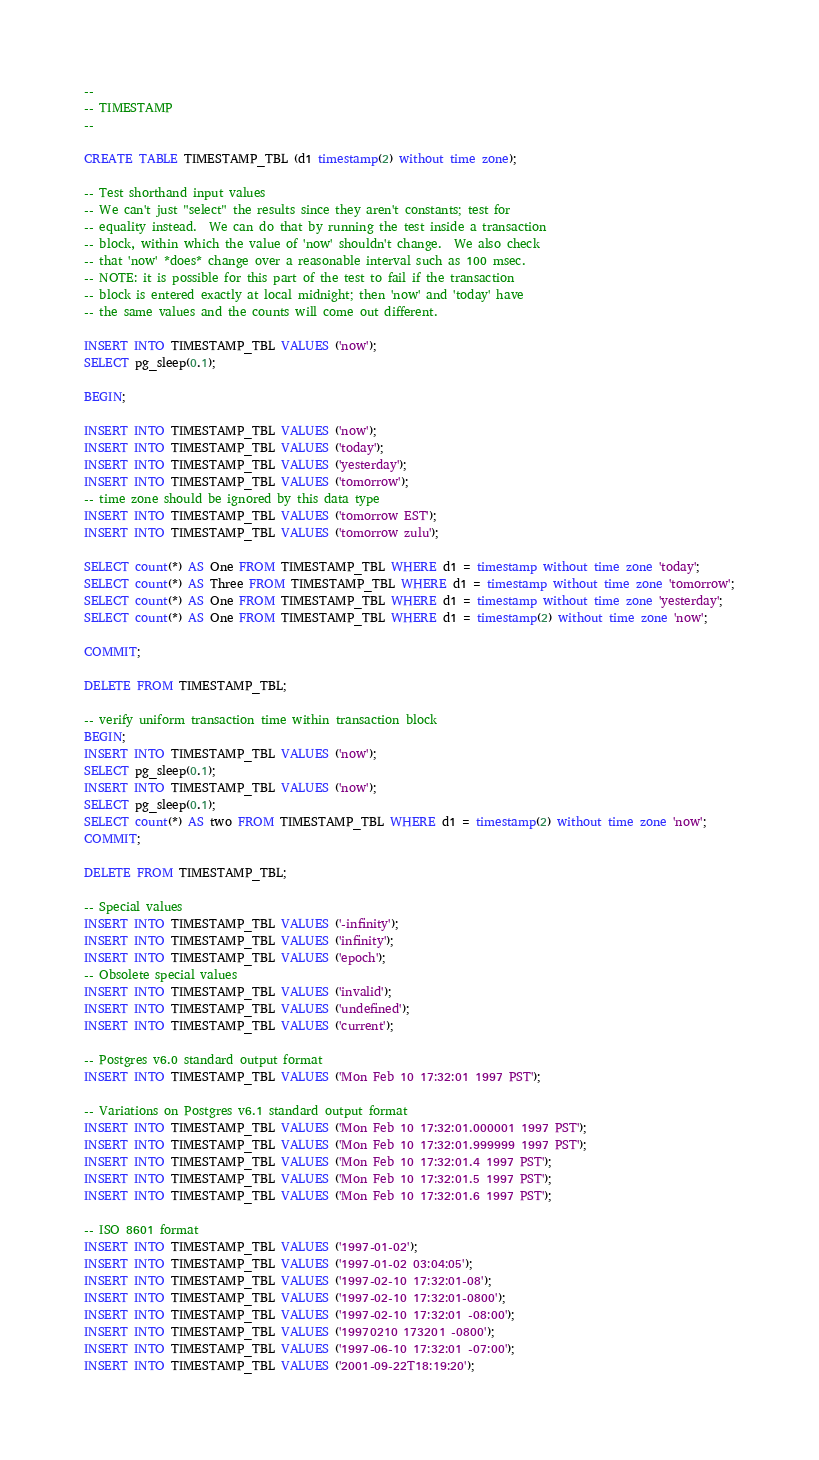<code> <loc_0><loc_0><loc_500><loc_500><_SQL_>--
-- TIMESTAMP
--

CREATE TABLE TIMESTAMP_TBL (d1 timestamp(2) without time zone);

-- Test shorthand input values
-- We can't just "select" the results since they aren't constants; test for
-- equality instead.  We can do that by running the test inside a transaction
-- block, within which the value of 'now' shouldn't change.  We also check
-- that 'now' *does* change over a reasonable interval such as 100 msec.
-- NOTE: it is possible for this part of the test to fail if the transaction
-- block is entered exactly at local midnight; then 'now' and 'today' have
-- the same values and the counts will come out different.

INSERT INTO TIMESTAMP_TBL VALUES ('now');
SELECT pg_sleep(0.1);

BEGIN;

INSERT INTO TIMESTAMP_TBL VALUES ('now');
INSERT INTO TIMESTAMP_TBL VALUES ('today');
INSERT INTO TIMESTAMP_TBL VALUES ('yesterday');
INSERT INTO TIMESTAMP_TBL VALUES ('tomorrow');
-- time zone should be ignored by this data type
INSERT INTO TIMESTAMP_TBL VALUES ('tomorrow EST');
INSERT INTO TIMESTAMP_TBL VALUES ('tomorrow zulu');

SELECT count(*) AS One FROM TIMESTAMP_TBL WHERE d1 = timestamp without time zone 'today';
SELECT count(*) AS Three FROM TIMESTAMP_TBL WHERE d1 = timestamp without time zone 'tomorrow';
SELECT count(*) AS One FROM TIMESTAMP_TBL WHERE d1 = timestamp without time zone 'yesterday';
SELECT count(*) AS One FROM TIMESTAMP_TBL WHERE d1 = timestamp(2) without time zone 'now';

COMMIT;

DELETE FROM TIMESTAMP_TBL;

-- verify uniform transaction time within transaction block
BEGIN;
INSERT INTO TIMESTAMP_TBL VALUES ('now');
SELECT pg_sleep(0.1);
INSERT INTO TIMESTAMP_TBL VALUES ('now');
SELECT pg_sleep(0.1);
SELECT count(*) AS two FROM TIMESTAMP_TBL WHERE d1 = timestamp(2) without time zone 'now';
COMMIT;

DELETE FROM TIMESTAMP_TBL;

-- Special values
INSERT INTO TIMESTAMP_TBL VALUES ('-infinity');
INSERT INTO TIMESTAMP_TBL VALUES ('infinity');
INSERT INTO TIMESTAMP_TBL VALUES ('epoch');
-- Obsolete special values
INSERT INTO TIMESTAMP_TBL VALUES ('invalid');
INSERT INTO TIMESTAMP_TBL VALUES ('undefined');
INSERT INTO TIMESTAMP_TBL VALUES ('current');

-- Postgres v6.0 standard output format
INSERT INTO TIMESTAMP_TBL VALUES ('Mon Feb 10 17:32:01 1997 PST');

-- Variations on Postgres v6.1 standard output format
INSERT INTO TIMESTAMP_TBL VALUES ('Mon Feb 10 17:32:01.000001 1997 PST');
INSERT INTO TIMESTAMP_TBL VALUES ('Mon Feb 10 17:32:01.999999 1997 PST');
INSERT INTO TIMESTAMP_TBL VALUES ('Mon Feb 10 17:32:01.4 1997 PST');
INSERT INTO TIMESTAMP_TBL VALUES ('Mon Feb 10 17:32:01.5 1997 PST');
INSERT INTO TIMESTAMP_TBL VALUES ('Mon Feb 10 17:32:01.6 1997 PST');

-- ISO 8601 format
INSERT INTO TIMESTAMP_TBL VALUES ('1997-01-02');
INSERT INTO TIMESTAMP_TBL VALUES ('1997-01-02 03:04:05');
INSERT INTO TIMESTAMP_TBL VALUES ('1997-02-10 17:32:01-08');
INSERT INTO TIMESTAMP_TBL VALUES ('1997-02-10 17:32:01-0800');
INSERT INTO TIMESTAMP_TBL VALUES ('1997-02-10 17:32:01 -08:00');
INSERT INTO TIMESTAMP_TBL VALUES ('19970210 173201 -0800');
INSERT INTO TIMESTAMP_TBL VALUES ('1997-06-10 17:32:01 -07:00');
INSERT INTO TIMESTAMP_TBL VALUES ('2001-09-22T18:19:20');
</code> 